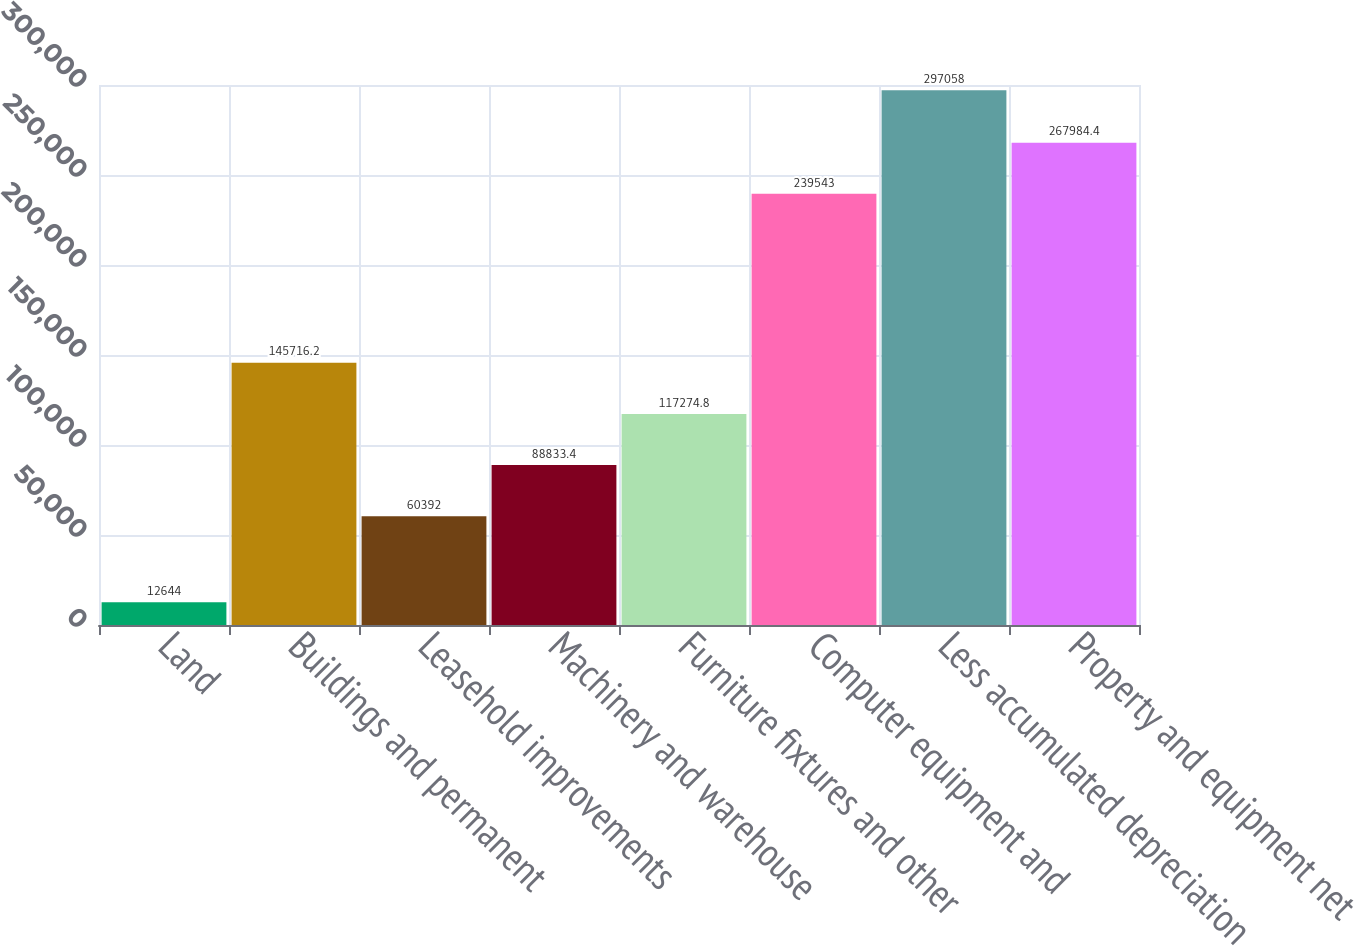Convert chart to OTSL. <chart><loc_0><loc_0><loc_500><loc_500><bar_chart><fcel>Land<fcel>Buildings and permanent<fcel>Leasehold improvements<fcel>Machinery and warehouse<fcel>Furniture fixtures and other<fcel>Computer equipment and<fcel>Less accumulated depreciation<fcel>Property and equipment net<nl><fcel>12644<fcel>145716<fcel>60392<fcel>88833.4<fcel>117275<fcel>239543<fcel>297058<fcel>267984<nl></chart> 